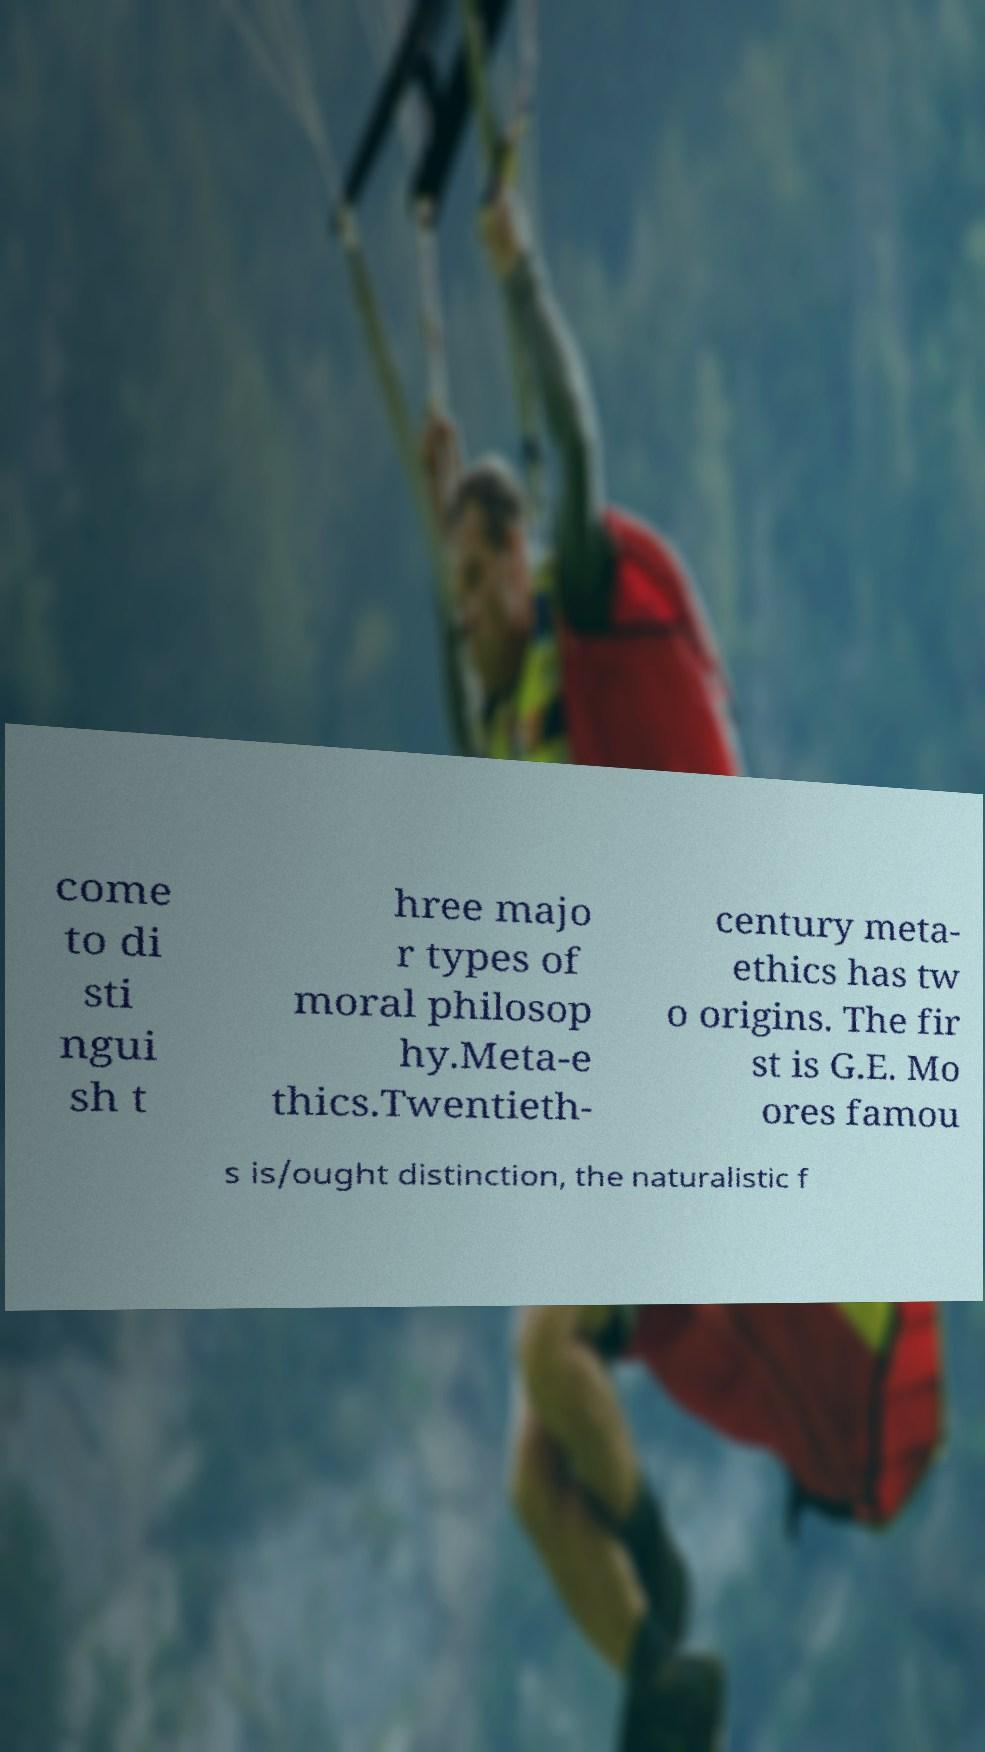What messages or text are displayed in this image? I need them in a readable, typed format. come to di sti ngui sh t hree majo r types of moral philosop hy.Meta-e thics.Twentieth- century meta- ethics has tw o origins. The fir st is G.E. Mo ores famou s is/ought distinction, the naturalistic f 